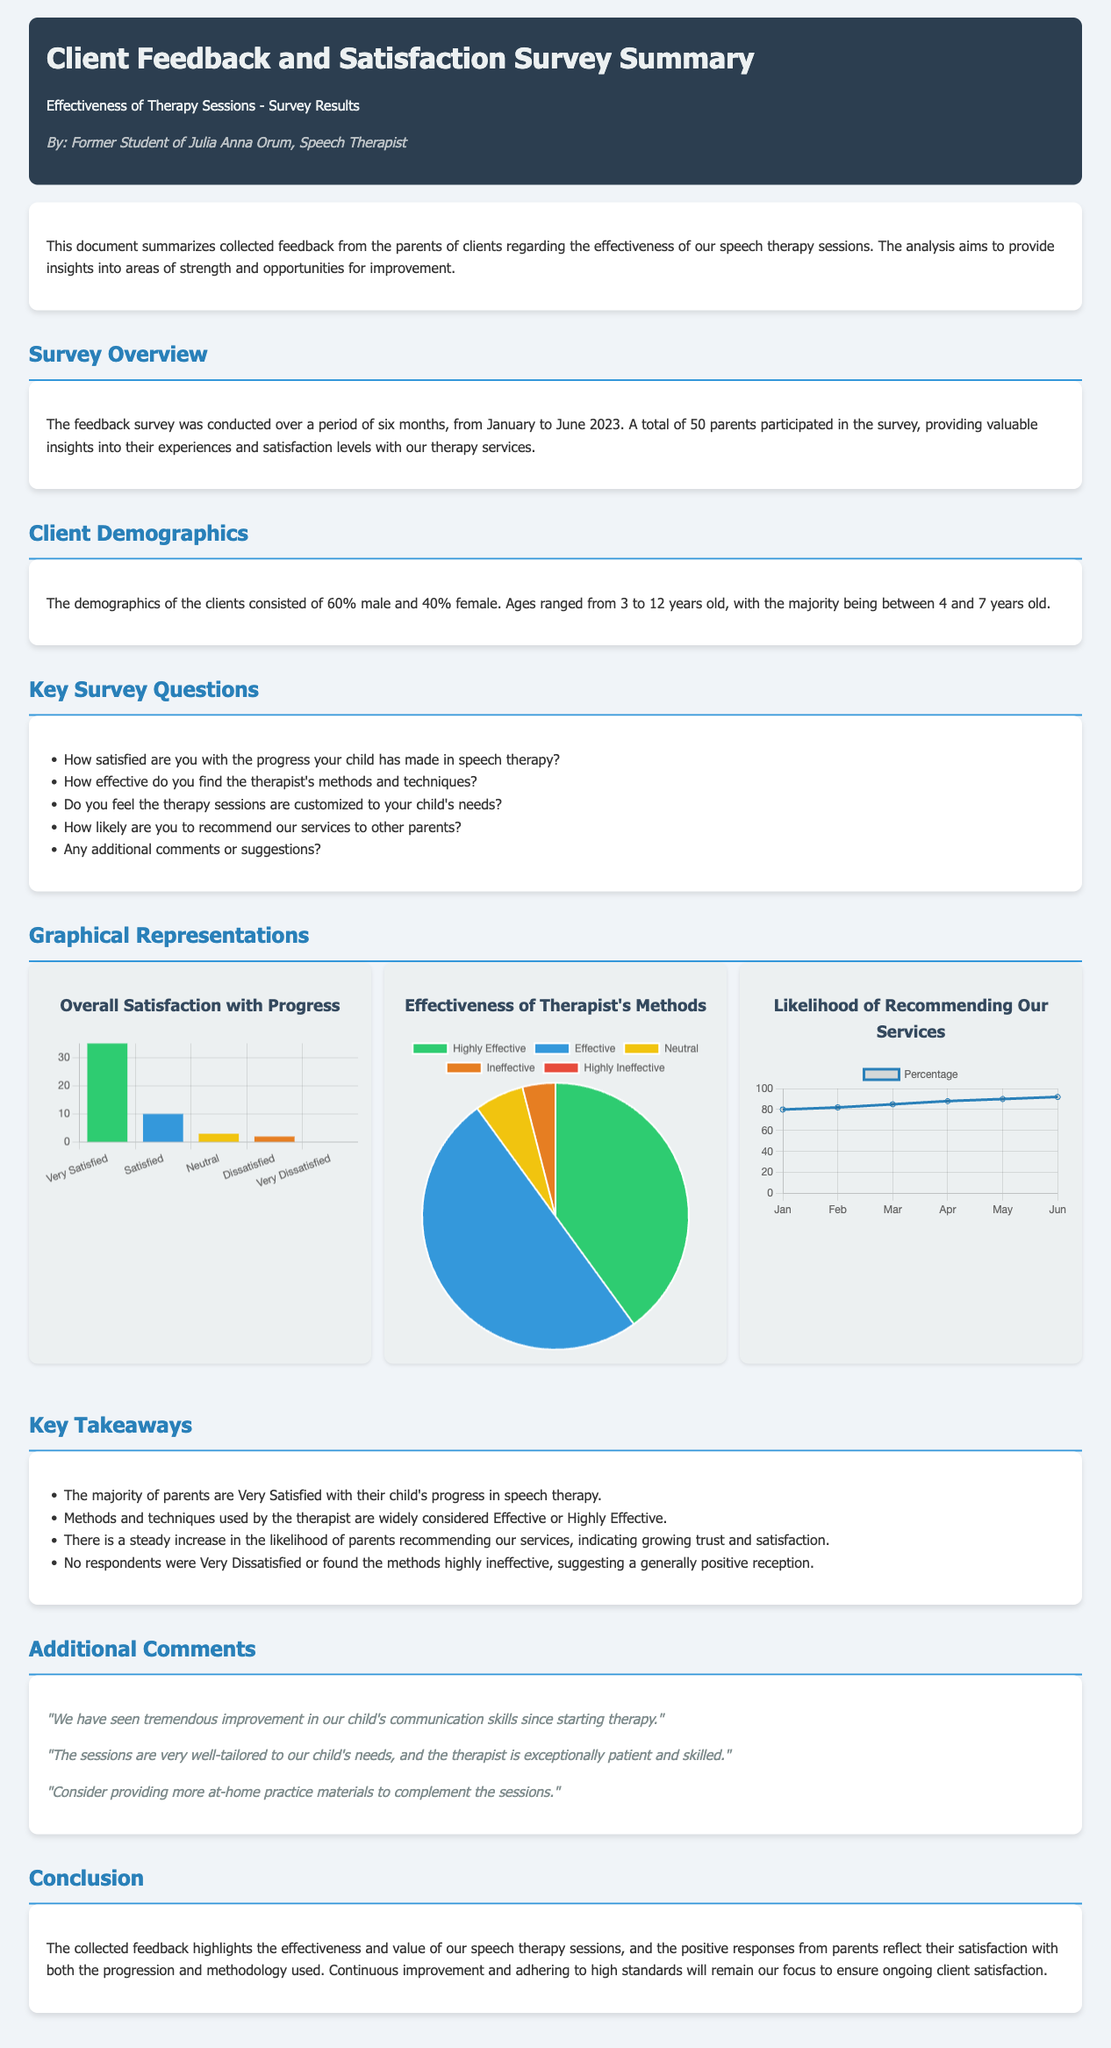how many parents participated in the survey? The document states that a total of 50 parents participated in the survey, providing feedback on the effectiveness of therapy sessions.
Answer: 50 what percentage of male clients were reported? The document provides demographic details stating that 60% of the clients are male.
Answer: 60% what was the age range of clients? The document mentions that ages ranged from 3 to 12 years old, highlighting important client demographics.
Answer: 3 to 12 years old how satisfied are the majority of parents with their child's progress in therapy? The key takeaways section summarizes that the majority of parents are Very Satisfied with their child's progress.
Answer: Very Satisfied what is the highest rating category for the effectiveness of therapy methods? According to the effectiveness chart data, the highest rating category is Highly Effective.
Answer: Highly Effective what does the likelihood of recommending services indicate over the months? The recommendation chart shows a steady increase, indicating growing trust and satisfaction among parents over time.
Answer: Steady increase what color represents Very Satisfied in the satisfaction chart? The satisfaction chart uses the color green (specifically, #2ecc71) to represent Very Satisfied.
Answer: Green how many comments were provided in the additional comments section? The document lists three comments from parents about their experiences and suggestions for improvement.
Answer: Three what is the maximum percentage indicated in the recommendation chart? The recommendation chart indicates a maximum percentage of 92 by June.
Answer: 92 